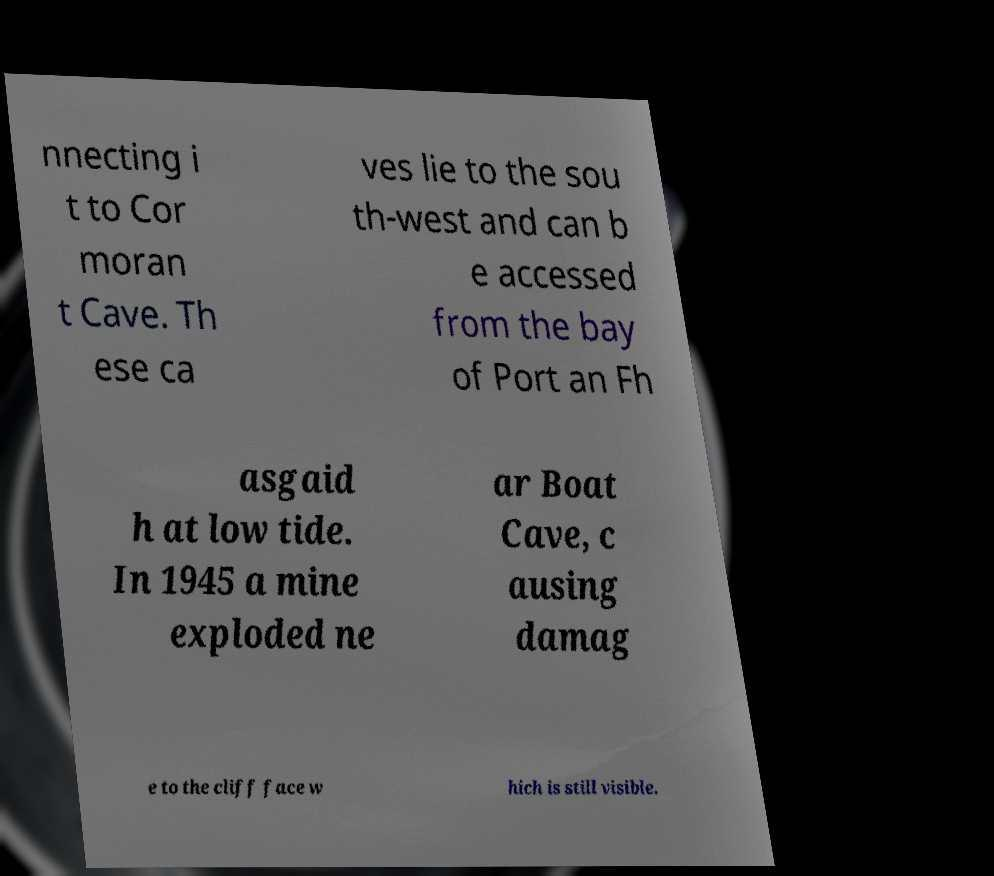There's text embedded in this image that I need extracted. Can you transcribe it verbatim? nnecting i t to Cor moran t Cave. Th ese ca ves lie to the sou th-west and can b e accessed from the bay of Port an Fh asgaid h at low tide. In 1945 a mine exploded ne ar Boat Cave, c ausing damag e to the cliff face w hich is still visible. 